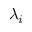<formula> <loc_0><loc_0><loc_500><loc_500>\lambda _ { i }</formula> 